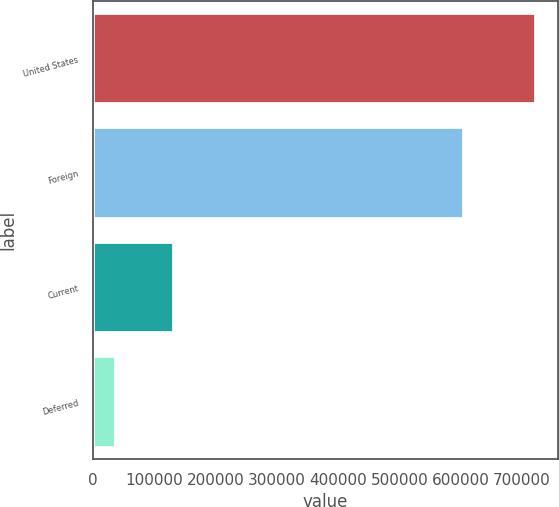<chart> <loc_0><loc_0><loc_500><loc_500><bar_chart><fcel>United States<fcel>Foreign<fcel>Current<fcel>Deferred<nl><fcel>722925<fcel>605716<fcel>132420<fcel>37316<nl></chart> 